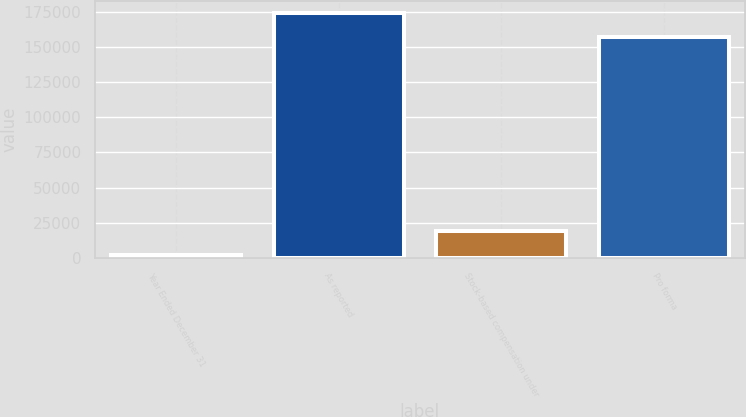Convert chart to OTSL. <chart><loc_0><loc_0><loc_500><loc_500><bar_chart><fcel>Year Ended December 31<fcel>As reported<fcel>Stock-based compensation under<fcel>Pro forma<nl><fcel>2001<fcel>173812<fcel>18782.4<fcel>157031<nl></chart> 